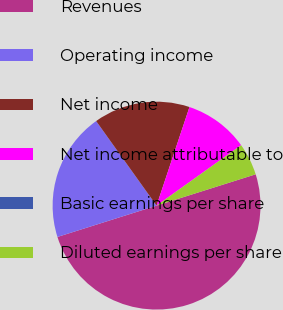Convert chart. <chart><loc_0><loc_0><loc_500><loc_500><pie_chart><fcel>Revenues<fcel>Operating income<fcel>Net income<fcel>Net income attributable to<fcel>Basic earnings per share<fcel>Diluted earnings per share<nl><fcel>50.0%<fcel>20.0%<fcel>15.0%<fcel>10.0%<fcel>0.0%<fcel>5.0%<nl></chart> 